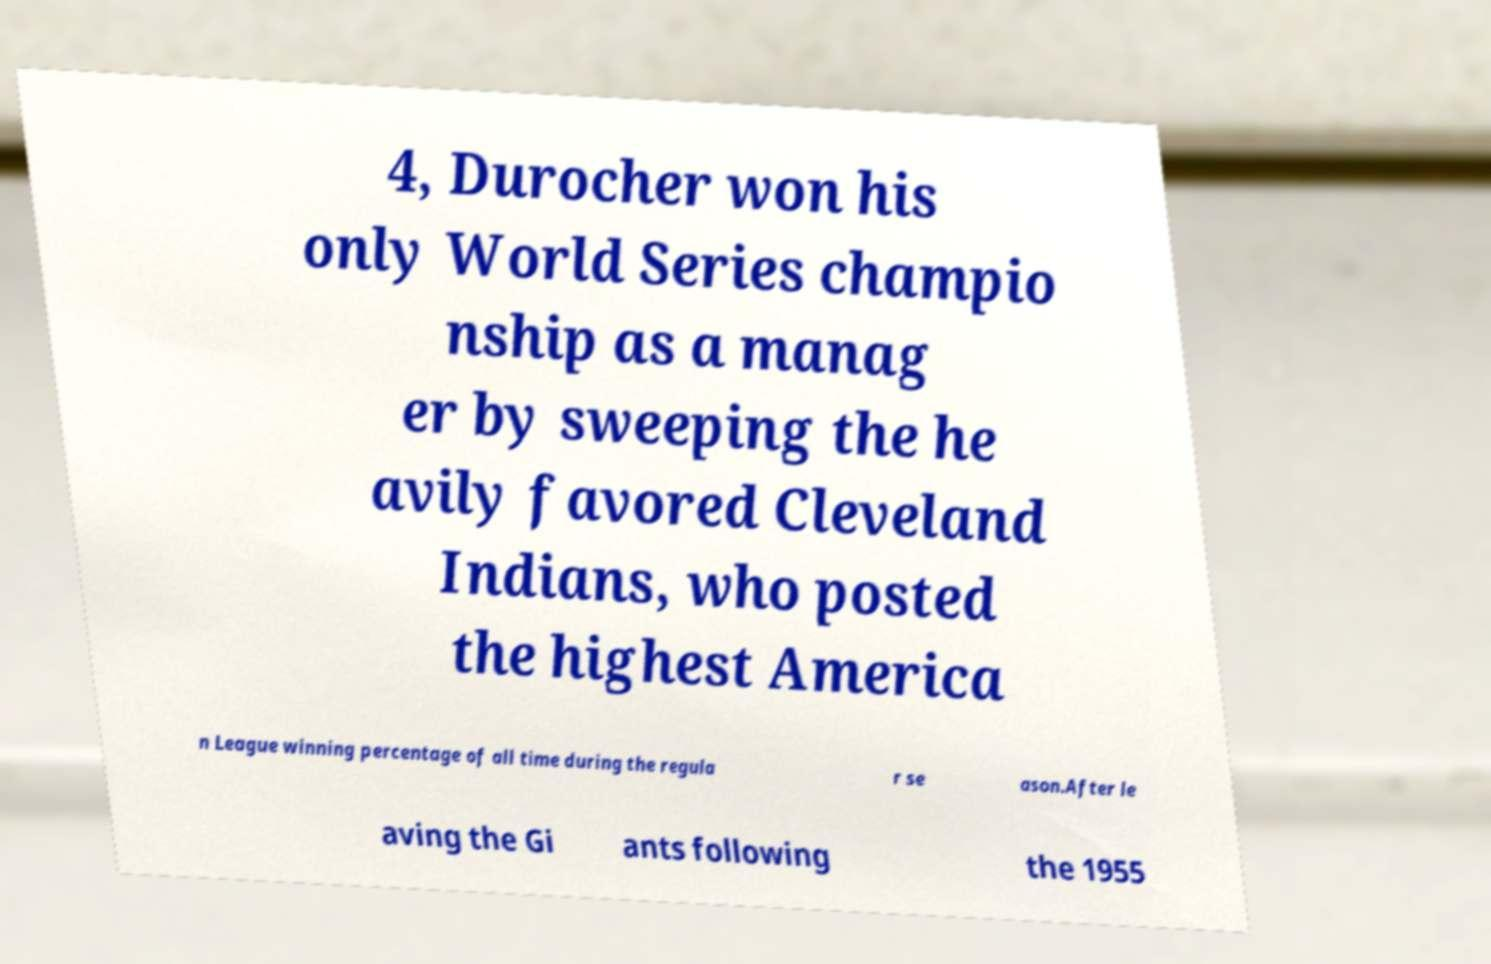Please identify and transcribe the text found in this image. 4, Durocher won his only World Series champio nship as a manag er by sweeping the he avily favored Cleveland Indians, who posted the highest America n League winning percentage of all time during the regula r se ason.After le aving the Gi ants following the 1955 